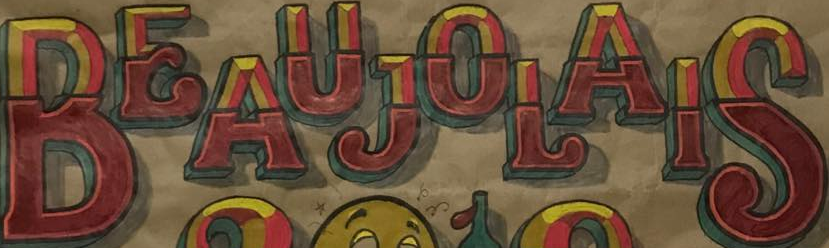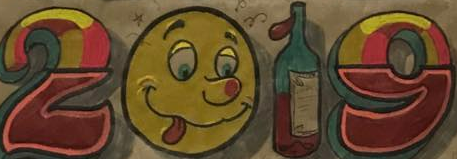What words can you see in these images in sequence, separated by a semicolon? BEAUJOLAIS; 2019 